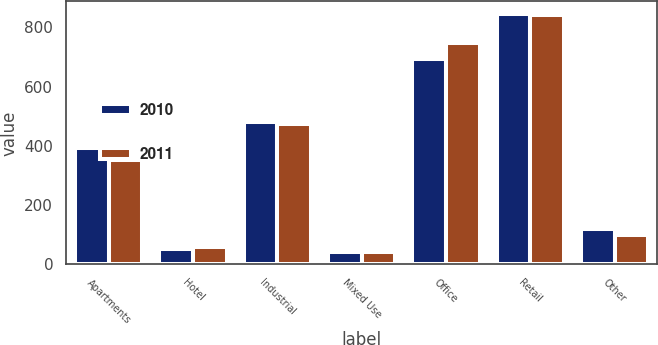Convert chart to OTSL. <chart><loc_0><loc_0><loc_500><loc_500><stacked_bar_chart><ecel><fcel>Apartments<fcel>Hotel<fcel>Industrial<fcel>Mixed Use<fcel>Office<fcel>Retail<fcel>Other<nl><fcel>2010<fcel>392<fcel>51<fcel>480<fcel>42<fcel>694<fcel>845<fcel>120<nl><fcel>2011<fcel>351<fcel>57<fcel>475<fcel>43<fcel>747<fcel>843<fcel>99<nl></chart> 